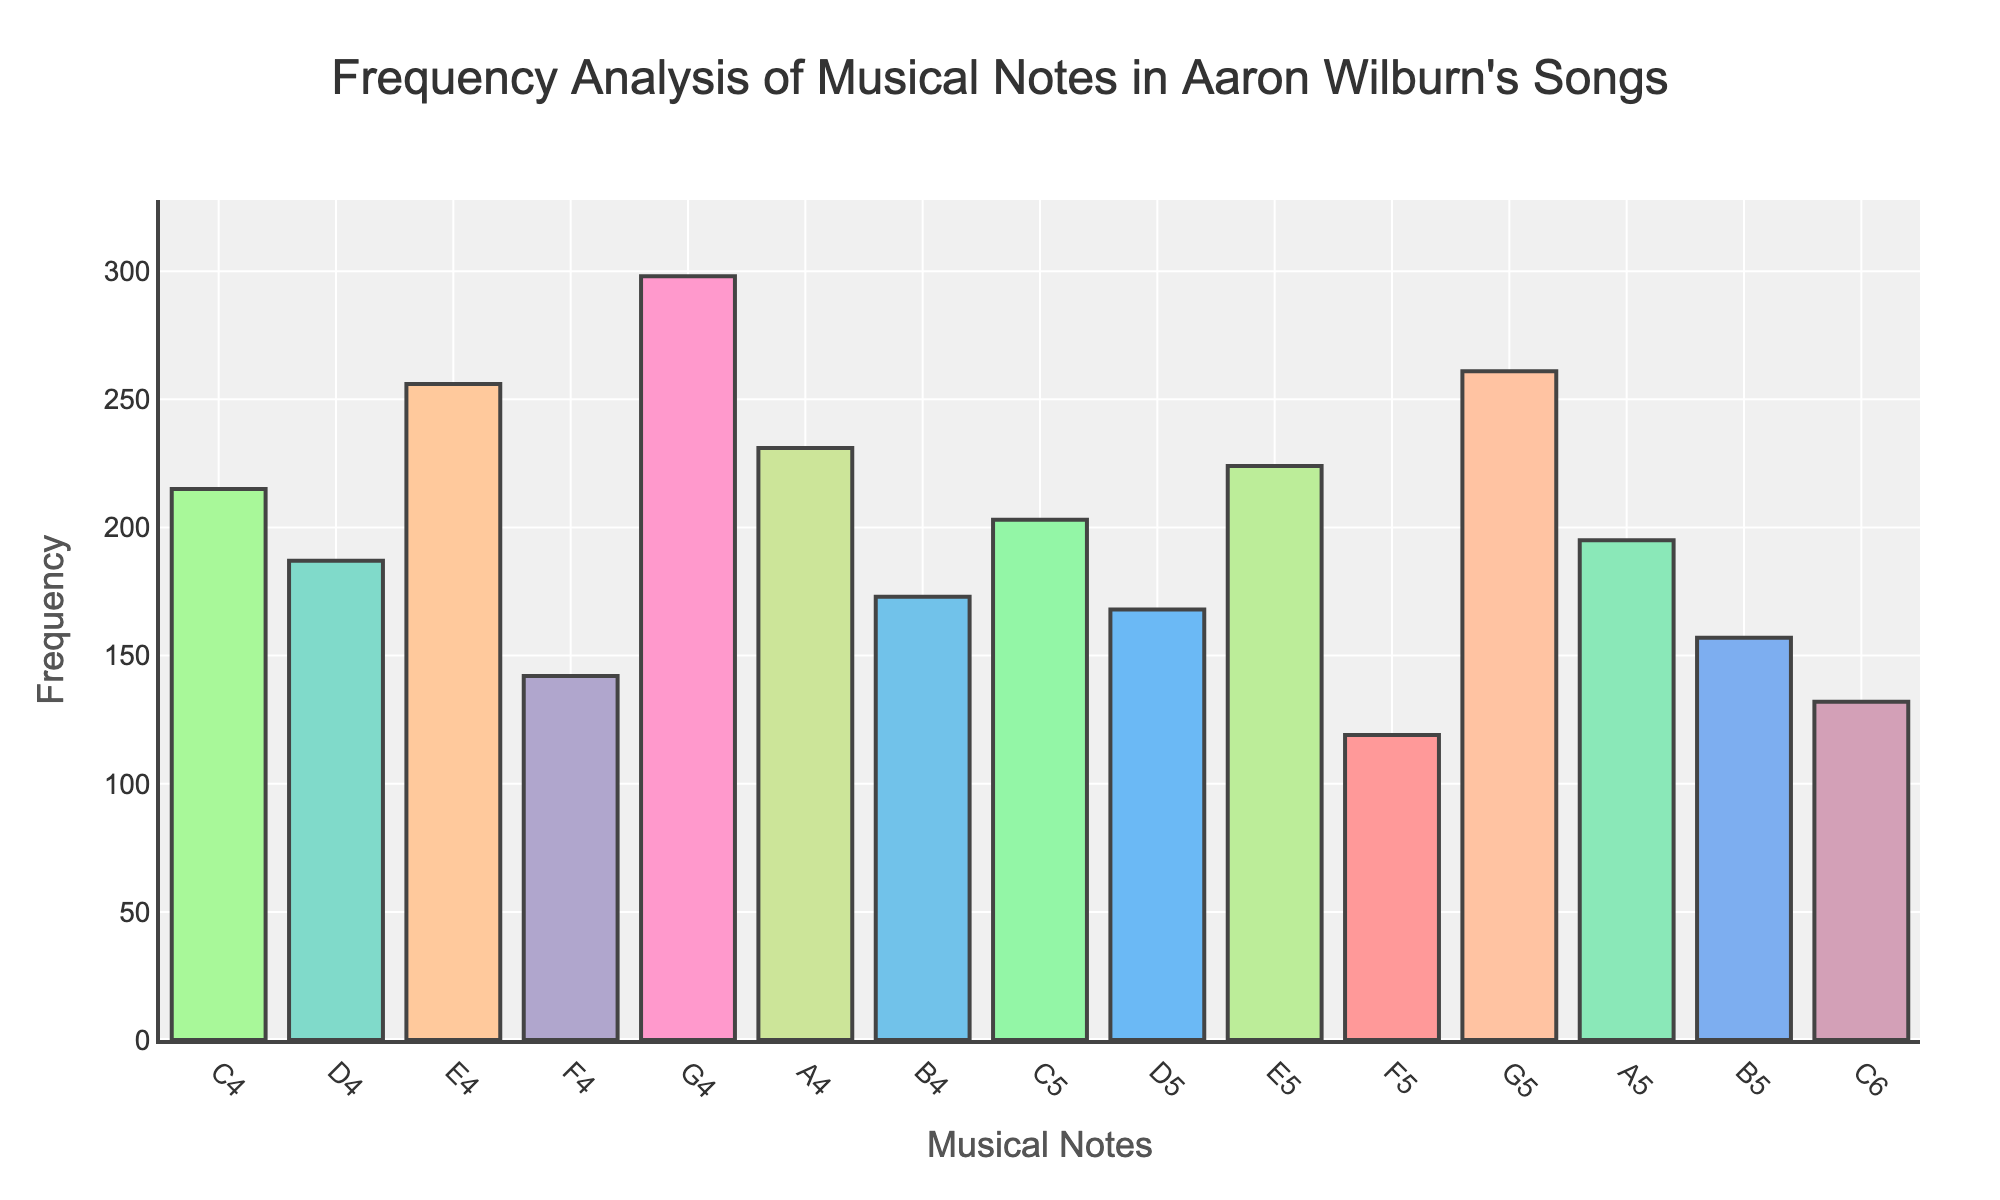What's the title of the figure? The title is displayed at the top of the figure, centered, and usually in a larger font size for prominence.
Answer: Frequency Analysis of Musical Notes in Aaron Wilburn's Songs What musical note has the highest frequency? By looking at the heights of the bars, the tallest one indicates the highest frequency. G4 has the tallest bar.
Answer: G4 Which musical note has the lowest frequency? The shortest bar denotes the lowest frequency, which can be found by visually scanning the figure. F5 has the shortest bar.
Answer: F5 How many different musical notes are displayed on the x-axis? Count the number of unique labels displayed on the x-axis, corresponding to the musical notes.
Answer: 15 What is the frequency of note C5? Find the bar corresponding to C5 on the x-axis and check the height, which is also annotated.
Answer: 203 Which note has a higher frequency, E4 or D5? Compare the heights of the bars for E4 and D5. E4 has a taller bar than D5.
Answer: E4 What is the difference in frequency between A4 and B4? Subtract the frequency of B4 from A4, which can be done by referring to the heights of the respective bars. A4 (231) - B4 (173) = 58.
Answer: 58 What's the average frequency of notes in the 5th octave (C5 to B5)? Add the frequencies of notes from C5 to B5 and divide by the number of notes. Frequencies: 203, 168, 224, 119, 261, 195, 157. Sum: 1327. Average: 1327 / 7 ≈ 189.57.
Answer: 189.57 Are there more notes in the 4th octave (C4 to B4) or the 5th octave (C5 to B5)? Count the number of notes in each octave. Both octaves have 7 notes.
Answer: Equal What color is used for the highest frequency note? Refer to the color used for the bar with the highest frequency. The highest frequency (G4) is colored according to the custom color scale.
Answer: #66B2FF 